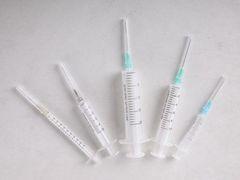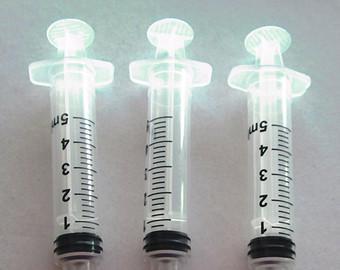The first image is the image on the left, the second image is the image on the right. Evaluate the accuracy of this statement regarding the images: "There are eight syringes in total.". Is it true? Answer yes or no. Yes. The first image is the image on the left, the second image is the image on the right. For the images shown, is this caption "At least one image shows a horizontal row of syringes arranged in order of size." true? Answer yes or no. No. 